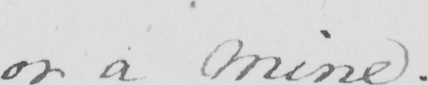What is written in this line of handwriting? or a mine . 